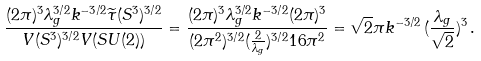<formula> <loc_0><loc_0><loc_500><loc_500>\frac { ( 2 \pi ) ^ { 3 } \lambda _ { g } ^ { 3 / 2 } k ^ { - 3 / 2 } \widetilde { \tau } ( S ^ { 3 } ) ^ { 3 / 2 } } { V ( S ^ { 3 } ) ^ { 3 / 2 } V ( S U ( 2 ) ) } = \frac { ( 2 \pi ) ^ { 3 } \lambda _ { g } ^ { 3 / 2 } k ^ { - 3 / 2 } ( 2 \pi ) ^ { 3 } } { ( 2 \pi ^ { 2 } ) ^ { 3 / 2 } ( \frac { 2 } { \lambda _ { g } } ) ^ { 3 / 2 } 1 6 \pi ^ { 2 } } = \sqrt { 2 } { \pi } k ^ { - 3 / 2 } \, ( \frac { \lambda _ { g } } { \sqrt { 2 } } ) ^ { 3 } \, .</formula> 